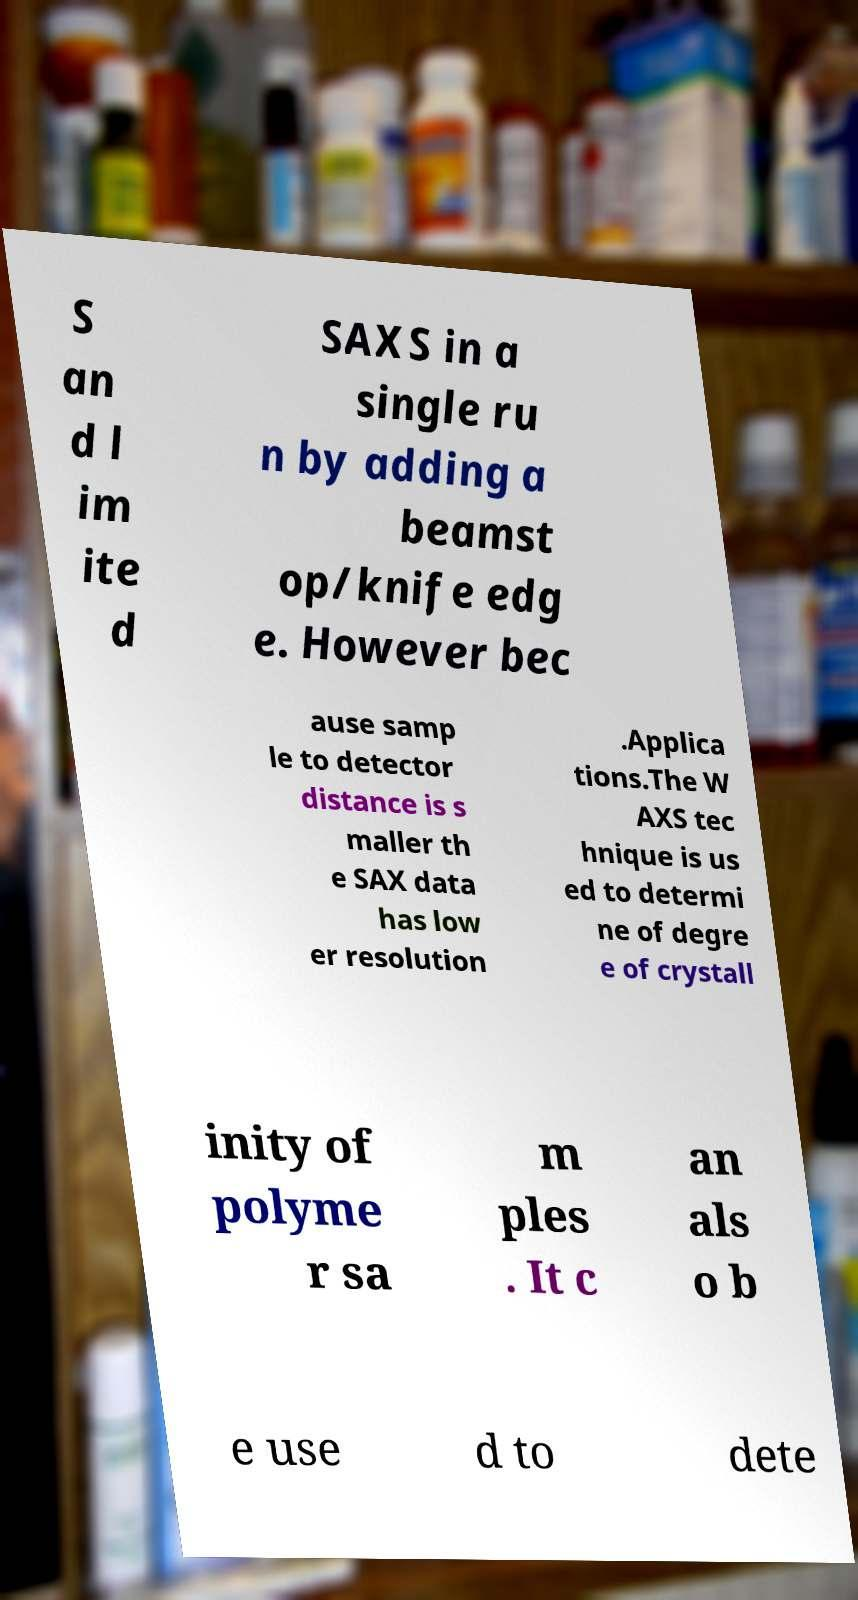I need the written content from this picture converted into text. Can you do that? S an d l im ite d SAXS in a single ru n by adding a beamst op/knife edg e. However bec ause samp le to detector distance is s maller th e SAX data has low er resolution .Applica tions.The W AXS tec hnique is us ed to determi ne of degre e of crystall inity of polyme r sa m ples . It c an als o b e use d to dete 